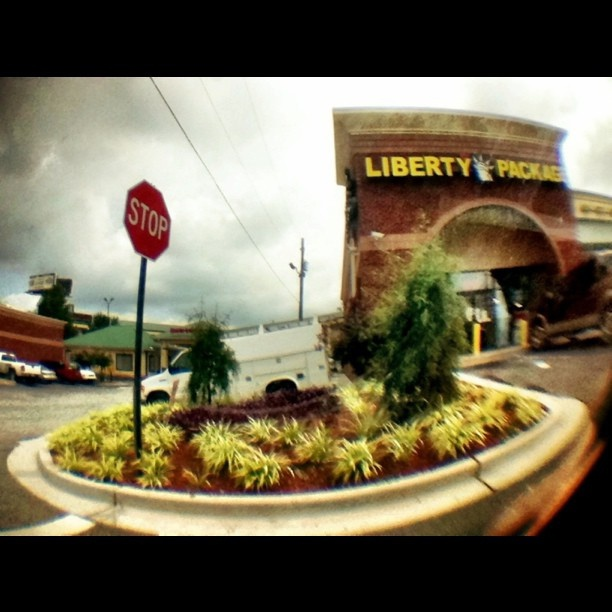Describe the objects in this image and their specific colors. I can see truck in black, beige, and tan tones, car in black, maroon, and gray tones, stop sign in black, maroon, brown, and darkgray tones, car in black, maroon, beige, and gray tones, and car in black, beige, and olive tones in this image. 